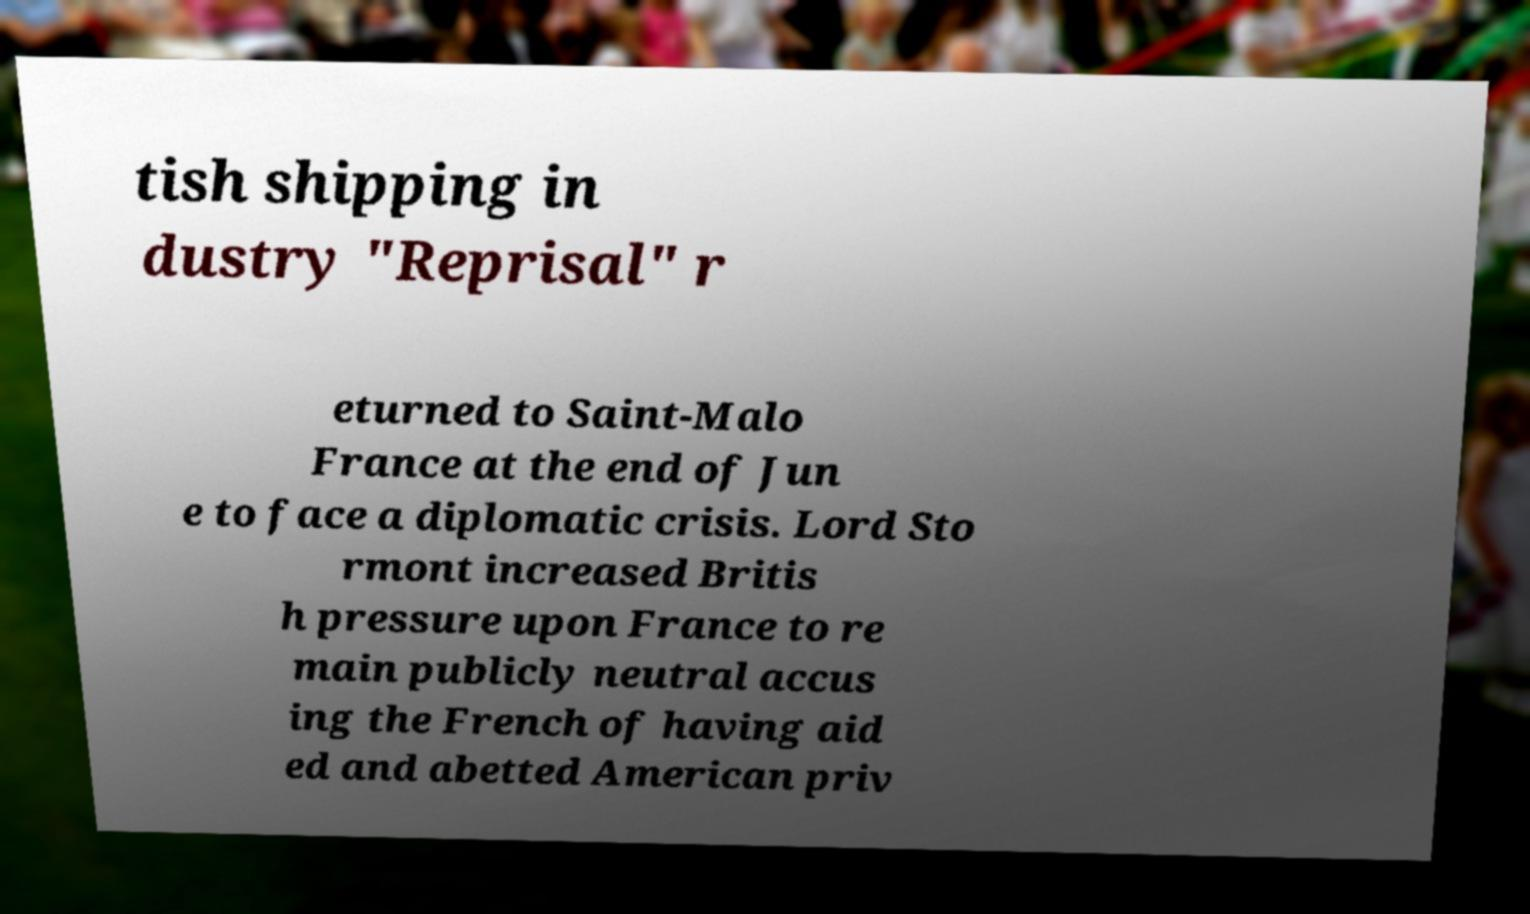Could you extract and type out the text from this image? tish shipping in dustry "Reprisal" r eturned to Saint-Malo France at the end of Jun e to face a diplomatic crisis. Lord Sto rmont increased Britis h pressure upon France to re main publicly neutral accus ing the French of having aid ed and abetted American priv 